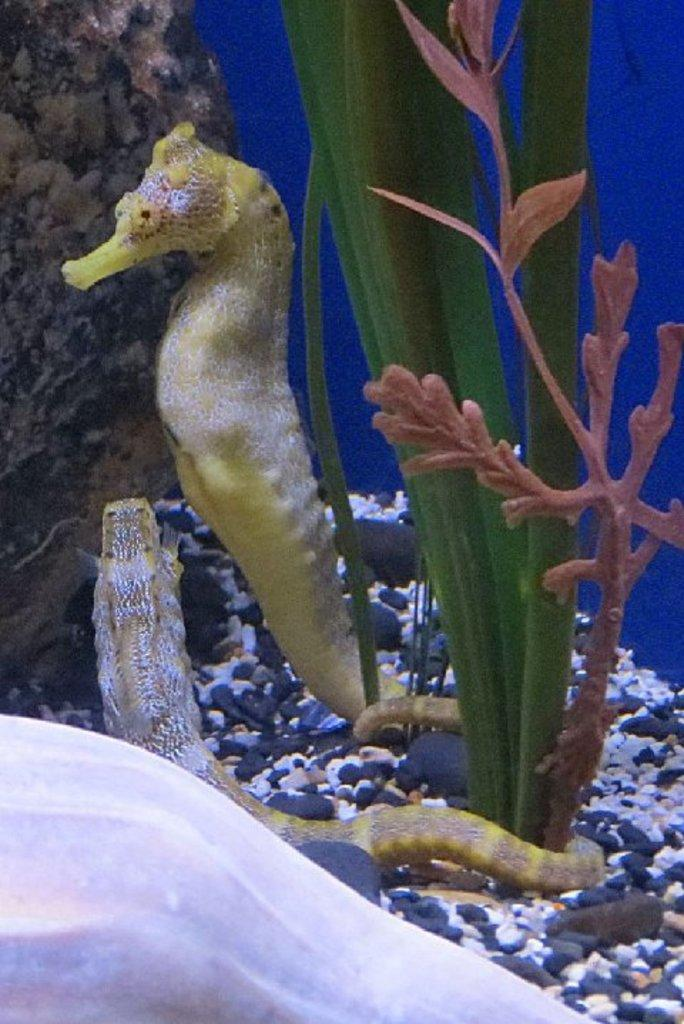What type of environment is depicted in the image? The image is an inside view of a fish tank. How many seahorses can be seen in the fish tank? There are two seahorses in the fish tank. What other objects are present in the fish tank? There are stones and a plant in the fish tank. Can you describe the white object at the bottom of the fish tank? There is a white color object at the bottom of the fish tank, which seems to be a shell. What is the opinion of the seahorses about the wire in the fish tank? There is no wire present in the fish tank. 